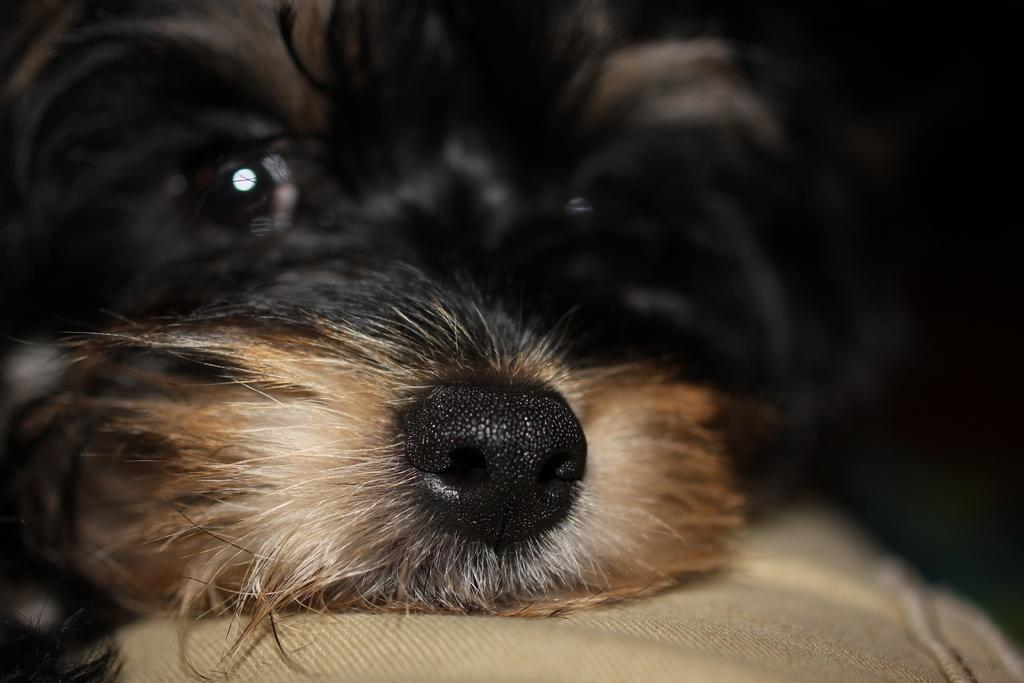What type of animal is present in the image? There is a dog in the image. Can you describe the dog's location in the image? The dog is on the surface in the image. What type of hate can be seen in the dog's expression in the image? There is no indication of hate in the dog's expression in the image, as dogs do not express emotions in the same way as humans. 